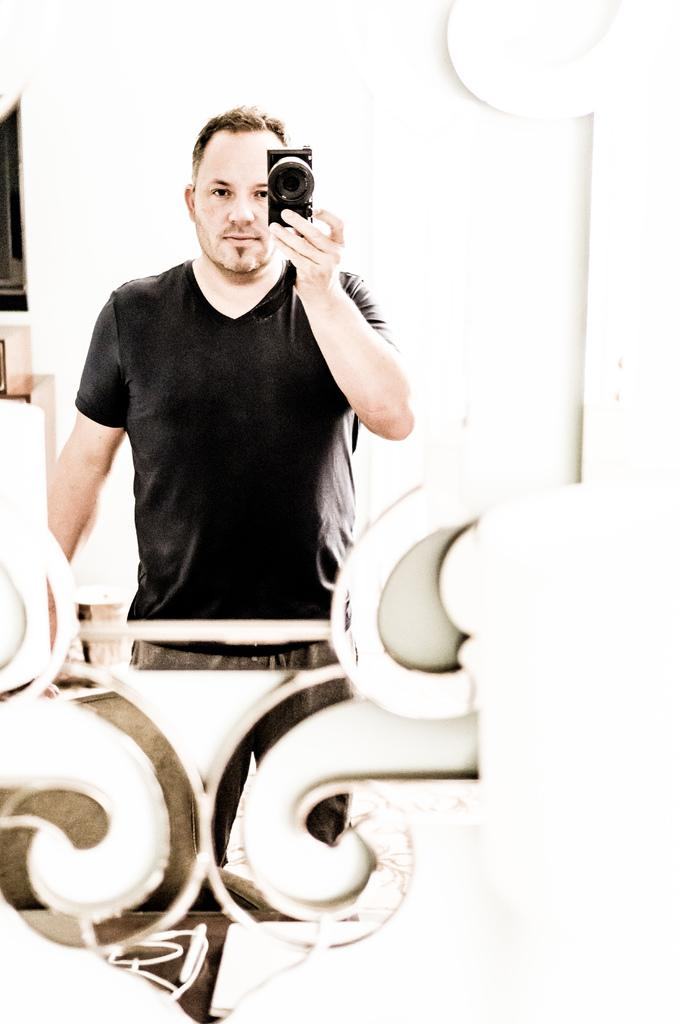What can be seen in the image? There is a person in the image. What is the person wearing? The person is wearing a black shirt. What is the person holding in their left hand? The person is holding a camera in their left hand. What other object is present in the image? There is a mirror in the image. What type of cap is the person wearing in the image? There is no cap visible in the image; the person is wearing a black shirt. 